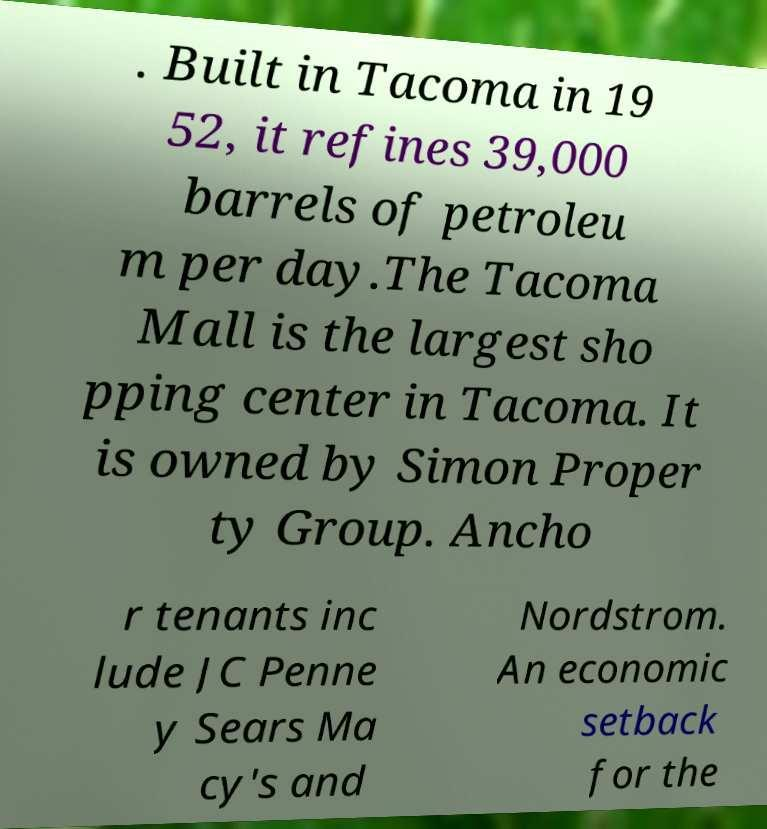Please read and relay the text visible in this image. What does it say? . Built in Tacoma in 19 52, it refines 39,000 barrels of petroleu m per day.The Tacoma Mall is the largest sho pping center in Tacoma. It is owned by Simon Proper ty Group. Ancho r tenants inc lude JC Penne y Sears Ma cy's and Nordstrom. An economic setback for the 